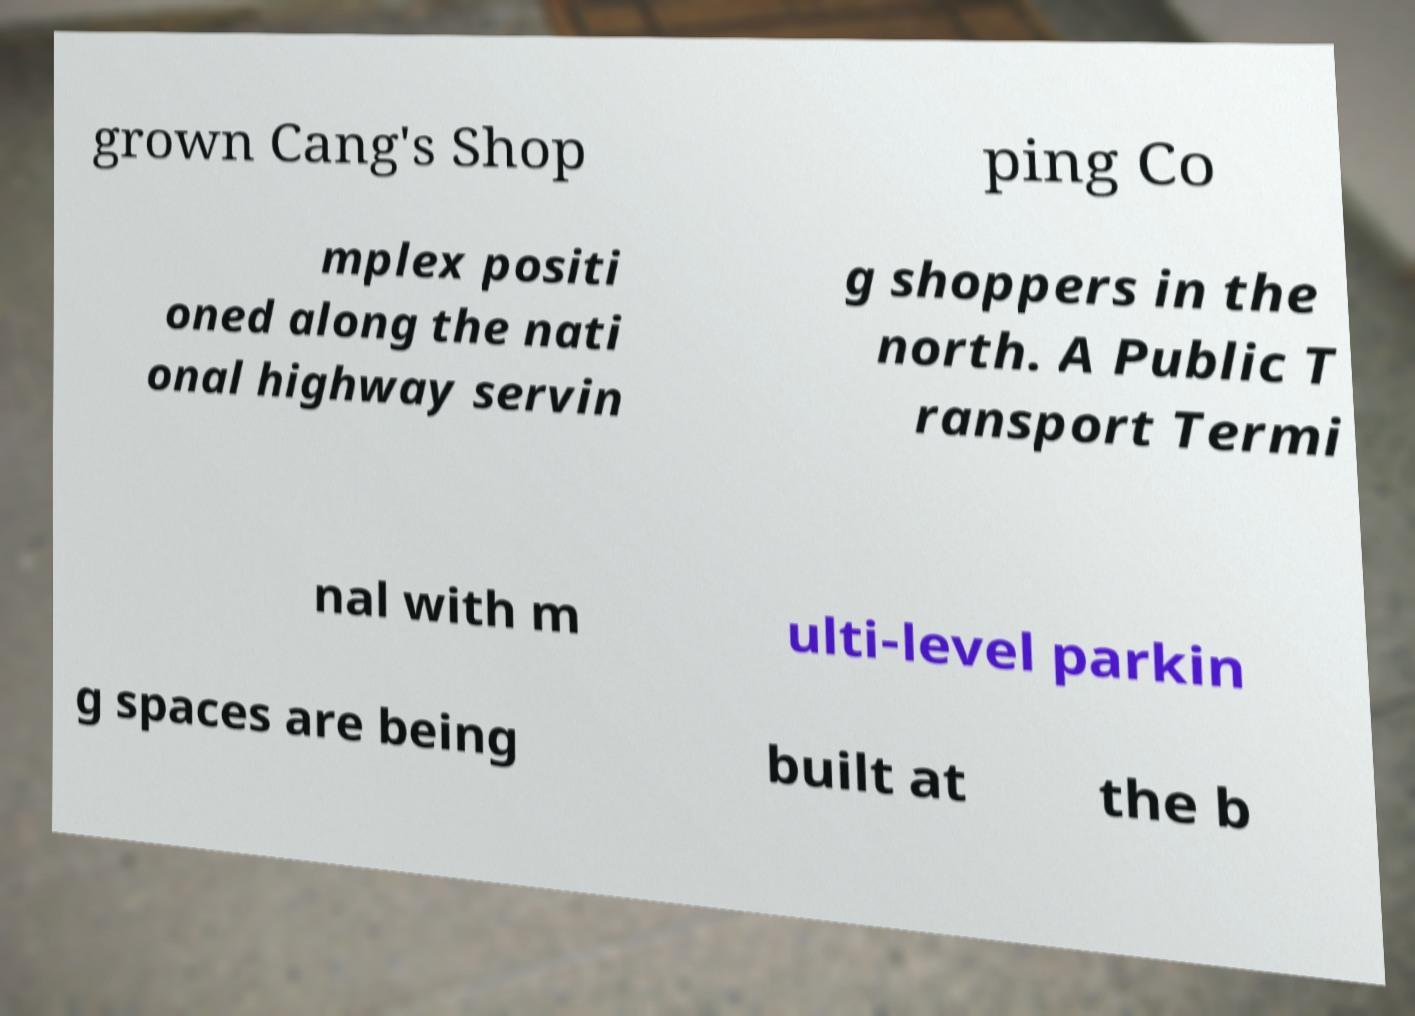Please read and relay the text visible in this image. What does it say? grown Cang's Shop ping Co mplex positi oned along the nati onal highway servin g shoppers in the north. A Public T ransport Termi nal with m ulti-level parkin g spaces are being built at the b 